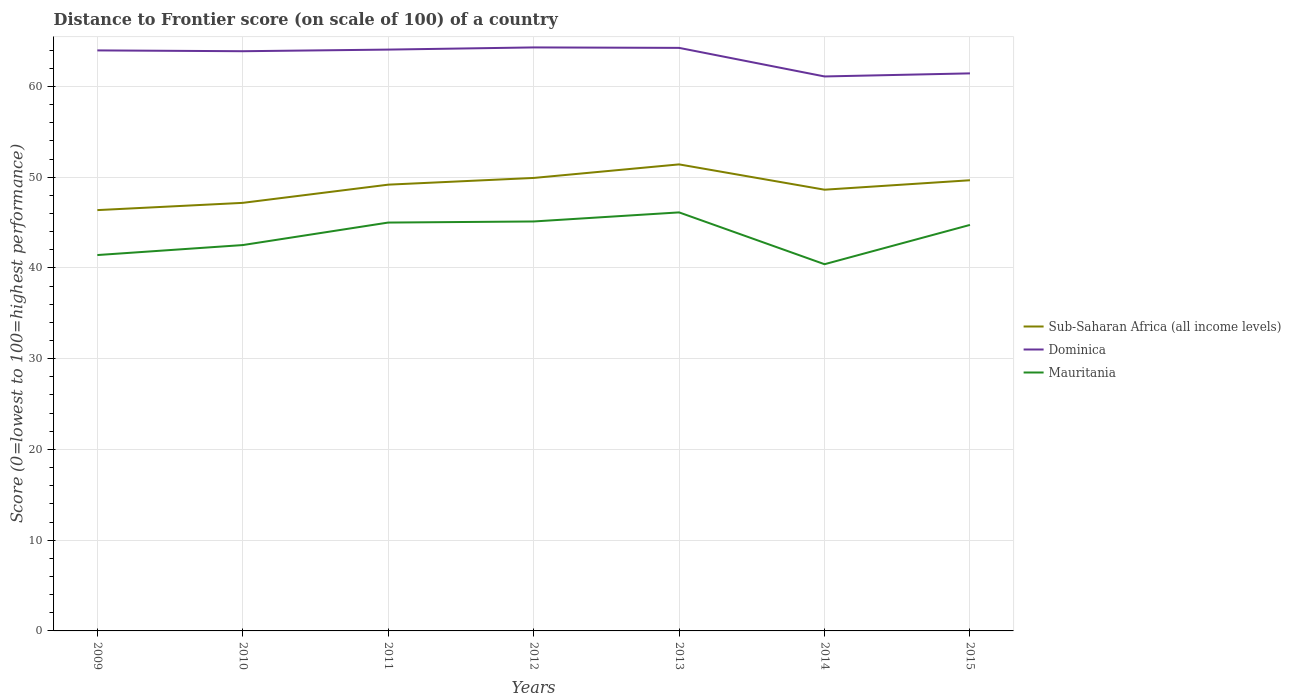How many different coloured lines are there?
Provide a succinct answer. 3. Does the line corresponding to Dominica intersect with the line corresponding to Mauritania?
Your answer should be very brief. No. Across all years, what is the maximum distance to frontier score of in Mauritania?
Give a very brief answer. 40.41. What is the total distance to frontier score of in Dominica in the graph?
Provide a short and direct response. 2.53. What is the difference between the highest and the second highest distance to frontier score of in Sub-Saharan Africa (all income levels)?
Your response must be concise. 5.04. What is the difference between the highest and the lowest distance to frontier score of in Sub-Saharan Africa (all income levels)?
Your answer should be compact. 4. How many years are there in the graph?
Provide a short and direct response. 7. What is the difference between two consecutive major ticks on the Y-axis?
Ensure brevity in your answer.  10. Are the values on the major ticks of Y-axis written in scientific E-notation?
Make the answer very short. No. Does the graph contain any zero values?
Provide a succinct answer. No. Where does the legend appear in the graph?
Keep it short and to the point. Center right. How many legend labels are there?
Your answer should be very brief. 3. What is the title of the graph?
Provide a short and direct response. Distance to Frontier score (on scale of 100) of a country. What is the label or title of the Y-axis?
Give a very brief answer. Score (0=lowest to 100=highest performance). What is the Score (0=lowest to 100=highest performance) of Sub-Saharan Africa (all income levels) in 2009?
Your answer should be very brief. 46.37. What is the Score (0=lowest to 100=highest performance) in Dominica in 2009?
Ensure brevity in your answer.  63.97. What is the Score (0=lowest to 100=highest performance) in Mauritania in 2009?
Provide a short and direct response. 41.42. What is the Score (0=lowest to 100=highest performance) of Sub-Saharan Africa (all income levels) in 2010?
Provide a short and direct response. 47.17. What is the Score (0=lowest to 100=highest performance) of Dominica in 2010?
Keep it short and to the point. 63.88. What is the Score (0=lowest to 100=highest performance) of Mauritania in 2010?
Provide a succinct answer. 42.52. What is the Score (0=lowest to 100=highest performance) of Sub-Saharan Africa (all income levels) in 2011?
Keep it short and to the point. 49.18. What is the Score (0=lowest to 100=highest performance) of Dominica in 2011?
Provide a short and direct response. 64.06. What is the Score (0=lowest to 100=highest performance) of Sub-Saharan Africa (all income levels) in 2012?
Provide a succinct answer. 49.92. What is the Score (0=lowest to 100=highest performance) in Dominica in 2012?
Make the answer very short. 64.3. What is the Score (0=lowest to 100=highest performance) of Mauritania in 2012?
Ensure brevity in your answer.  45.12. What is the Score (0=lowest to 100=highest performance) of Sub-Saharan Africa (all income levels) in 2013?
Ensure brevity in your answer.  51.41. What is the Score (0=lowest to 100=highest performance) in Dominica in 2013?
Ensure brevity in your answer.  64.25. What is the Score (0=lowest to 100=highest performance) of Mauritania in 2013?
Give a very brief answer. 46.12. What is the Score (0=lowest to 100=highest performance) in Sub-Saharan Africa (all income levels) in 2014?
Offer a very short reply. 48.62. What is the Score (0=lowest to 100=highest performance) of Dominica in 2014?
Keep it short and to the point. 61.1. What is the Score (0=lowest to 100=highest performance) in Mauritania in 2014?
Your answer should be very brief. 40.41. What is the Score (0=lowest to 100=highest performance) in Sub-Saharan Africa (all income levels) in 2015?
Make the answer very short. 49.66. What is the Score (0=lowest to 100=highest performance) of Dominica in 2015?
Your answer should be very brief. 61.44. What is the Score (0=lowest to 100=highest performance) in Mauritania in 2015?
Offer a terse response. 44.74. Across all years, what is the maximum Score (0=lowest to 100=highest performance) in Sub-Saharan Africa (all income levels)?
Your answer should be very brief. 51.41. Across all years, what is the maximum Score (0=lowest to 100=highest performance) of Dominica?
Your response must be concise. 64.3. Across all years, what is the maximum Score (0=lowest to 100=highest performance) of Mauritania?
Make the answer very short. 46.12. Across all years, what is the minimum Score (0=lowest to 100=highest performance) of Sub-Saharan Africa (all income levels)?
Make the answer very short. 46.37. Across all years, what is the minimum Score (0=lowest to 100=highest performance) in Dominica?
Offer a terse response. 61.1. Across all years, what is the minimum Score (0=lowest to 100=highest performance) of Mauritania?
Offer a terse response. 40.41. What is the total Score (0=lowest to 100=highest performance) in Sub-Saharan Africa (all income levels) in the graph?
Provide a succinct answer. 342.33. What is the total Score (0=lowest to 100=highest performance) of Dominica in the graph?
Ensure brevity in your answer.  443. What is the total Score (0=lowest to 100=highest performance) in Mauritania in the graph?
Ensure brevity in your answer.  305.33. What is the difference between the Score (0=lowest to 100=highest performance) in Sub-Saharan Africa (all income levels) in 2009 and that in 2010?
Your answer should be compact. -0.8. What is the difference between the Score (0=lowest to 100=highest performance) in Dominica in 2009 and that in 2010?
Your answer should be very brief. 0.09. What is the difference between the Score (0=lowest to 100=highest performance) in Mauritania in 2009 and that in 2010?
Offer a terse response. -1.1. What is the difference between the Score (0=lowest to 100=highest performance) of Sub-Saharan Africa (all income levels) in 2009 and that in 2011?
Your answer should be compact. -2.8. What is the difference between the Score (0=lowest to 100=highest performance) of Dominica in 2009 and that in 2011?
Offer a terse response. -0.09. What is the difference between the Score (0=lowest to 100=highest performance) in Mauritania in 2009 and that in 2011?
Your response must be concise. -3.58. What is the difference between the Score (0=lowest to 100=highest performance) of Sub-Saharan Africa (all income levels) in 2009 and that in 2012?
Give a very brief answer. -3.54. What is the difference between the Score (0=lowest to 100=highest performance) of Dominica in 2009 and that in 2012?
Ensure brevity in your answer.  -0.33. What is the difference between the Score (0=lowest to 100=highest performance) in Sub-Saharan Africa (all income levels) in 2009 and that in 2013?
Give a very brief answer. -5.04. What is the difference between the Score (0=lowest to 100=highest performance) in Dominica in 2009 and that in 2013?
Your response must be concise. -0.28. What is the difference between the Score (0=lowest to 100=highest performance) of Mauritania in 2009 and that in 2013?
Your answer should be very brief. -4.7. What is the difference between the Score (0=lowest to 100=highest performance) in Sub-Saharan Africa (all income levels) in 2009 and that in 2014?
Give a very brief answer. -2.25. What is the difference between the Score (0=lowest to 100=highest performance) in Dominica in 2009 and that in 2014?
Provide a short and direct response. 2.87. What is the difference between the Score (0=lowest to 100=highest performance) of Sub-Saharan Africa (all income levels) in 2009 and that in 2015?
Make the answer very short. -3.29. What is the difference between the Score (0=lowest to 100=highest performance) in Dominica in 2009 and that in 2015?
Provide a short and direct response. 2.53. What is the difference between the Score (0=lowest to 100=highest performance) in Mauritania in 2009 and that in 2015?
Your answer should be compact. -3.32. What is the difference between the Score (0=lowest to 100=highest performance) in Sub-Saharan Africa (all income levels) in 2010 and that in 2011?
Make the answer very short. -2.01. What is the difference between the Score (0=lowest to 100=highest performance) in Dominica in 2010 and that in 2011?
Provide a short and direct response. -0.18. What is the difference between the Score (0=lowest to 100=highest performance) of Mauritania in 2010 and that in 2011?
Your response must be concise. -2.48. What is the difference between the Score (0=lowest to 100=highest performance) in Sub-Saharan Africa (all income levels) in 2010 and that in 2012?
Ensure brevity in your answer.  -2.75. What is the difference between the Score (0=lowest to 100=highest performance) of Dominica in 2010 and that in 2012?
Provide a succinct answer. -0.42. What is the difference between the Score (0=lowest to 100=highest performance) of Sub-Saharan Africa (all income levels) in 2010 and that in 2013?
Your response must be concise. -4.24. What is the difference between the Score (0=lowest to 100=highest performance) of Dominica in 2010 and that in 2013?
Offer a very short reply. -0.37. What is the difference between the Score (0=lowest to 100=highest performance) of Sub-Saharan Africa (all income levels) in 2010 and that in 2014?
Your response must be concise. -1.45. What is the difference between the Score (0=lowest to 100=highest performance) in Dominica in 2010 and that in 2014?
Make the answer very short. 2.78. What is the difference between the Score (0=lowest to 100=highest performance) in Mauritania in 2010 and that in 2014?
Give a very brief answer. 2.11. What is the difference between the Score (0=lowest to 100=highest performance) of Sub-Saharan Africa (all income levels) in 2010 and that in 2015?
Offer a very short reply. -2.49. What is the difference between the Score (0=lowest to 100=highest performance) of Dominica in 2010 and that in 2015?
Give a very brief answer. 2.44. What is the difference between the Score (0=lowest to 100=highest performance) in Mauritania in 2010 and that in 2015?
Provide a succinct answer. -2.22. What is the difference between the Score (0=lowest to 100=highest performance) in Sub-Saharan Africa (all income levels) in 2011 and that in 2012?
Your response must be concise. -0.74. What is the difference between the Score (0=lowest to 100=highest performance) in Dominica in 2011 and that in 2012?
Make the answer very short. -0.24. What is the difference between the Score (0=lowest to 100=highest performance) of Mauritania in 2011 and that in 2012?
Keep it short and to the point. -0.12. What is the difference between the Score (0=lowest to 100=highest performance) of Sub-Saharan Africa (all income levels) in 2011 and that in 2013?
Your response must be concise. -2.23. What is the difference between the Score (0=lowest to 100=highest performance) in Dominica in 2011 and that in 2013?
Your response must be concise. -0.19. What is the difference between the Score (0=lowest to 100=highest performance) in Mauritania in 2011 and that in 2013?
Provide a succinct answer. -1.12. What is the difference between the Score (0=lowest to 100=highest performance) in Sub-Saharan Africa (all income levels) in 2011 and that in 2014?
Your answer should be very brief. 0.56. What is the difference between the Score (0=lowest to 100=highest performance) of Dominica in 2011 and that in 2014?
Ensure brevity in your answer.  2.96. What is the difference between the Score (0=lowest to 100=highest performance) in Mauritania in 2011 and that in 2014?
Give a very brief answer. 4.59. What is the difference between the Score (0=lowest to 100=highest performance) in Sub-Saharan Africa (all income levels) in 2011 and that in 2015?
Give a very brief answer. -0.49. What is the difference between the Score (0=lowest to 100=highest performance) of Dominica in 2011 and that in 2015?
Provide a succinct answer. 2.62. What is the difference between the Score (0=lowest to 100=highest performance) of Mauritania in 2011 and that in 2015?
Provide a succinct answer. 0.26. What is the difference between the Score (0=lowest to 100=highest performance) in Sub-Saharan Africa (all income levels) in 2012 and that in 2013?
Your answer should be compact. -1.49. What is the difference between the Score (0=lowest to 100=highest performance) in Sub-Saharan Africa (all income levels) in 2012 and that in 2014?
Your answer should be very brief. 1.3. What is the difference between the Score (0=lowest to 100=highest performance) in Mauritania in 2012 and that in 2014?
Give a very brief answer. 4.71. What is the difference between the Score (0=lowest to 100=highest performance) of Sub-Saharan Africa (all income levels) in 2012 and that in 2015?
Keep it short and to the point. 0.25. What is the difference between the Score (0=lowest to 100=highest performance) of Dominica in 2012 and that in 2015?
Give a very brief answer. 2.86. What is the difference between the Score (0=lowest to 100=highest performance) of Mauritania in 2012 and that in 2015?
Provide a succinct answer. 0.38. What is the difference between the Score (0=lowest to 100=highest performance) of Sub-Saharan Africa (all income levels) in 2013 and that in 2014?
Give a very brief answer. 2.79. What is the difference between the Score (0=lowest to 100=highest performance) in Dominica in 2013 and that in 2014?
Offer a terse response. 3.15. What is the difference between the Score (0=lowest to 100=highest performance) of Mauritania in 2013 and that in 2014?
Ensure brevity in your answer.  5.71. What is the difference between the Score (0=lowest to 100=highest performance) of Sub-Saharan Africa (all income levels) in 2013 and that in 2015?
Offer a very short reply. 1.75. What is the difference between the Score (0=lowest to 100=highest performance) in Dominica in 2013 and that in 2015?
Your answer should be compact. 2.81. What is the difference between the Score (0=lowest to 100=highest performance) of Mauritania in 2013 and that in 2015?
Provide a short and direct response. 1.38. What is the difference between the Score (0=lowest to 100=highest performance) of Sub-Saharan Africa (all income levels) in 2014 and that in 2015?
Give a very brief answer. -1.04. What is the difference between the Score (0=lowest to 100=highest performance) of Dominica in 2014 and that in 2015?
Provide a short and direct response. -0.34. What is the difference between the Score (0=lowest to 100=highest performance) in Mauritania in 2014 and that in 2015?
Make the answer very short. -4.33. What is the difference between the Score (0=lowest to 100=highest performance) of Sub-Saharan Africa (all income levels) in 2009 and the Score (0=lowest to 100=highest performance) of Dominica in 2010?
Your answer should be very brief. -17.51. What is the difference between the Score (0=lowest to 100=highest performance) of Sub-Saharan Africa (all income levels) in 2009 and the Score (0=lowest to 100=highest performance) of Mauritania in 2010?
Provide a succinct answer. 3.85. What is the difference between the Score (0=lowest to 100=highest performance) in Dominica in 2009 and the Score (0=lowest to 100=highest performance) in Mauritania in 2010?
Ensure brevity in your answer.  21.45. What is the difference between the Score (0=lowest to 100=highest performance) in Sub-Saharan Africa (all income levels) in 2009 and the Score (0=lowest to 100=highest performance) in Dominica in 2011?
Give a very brief answer. -17.69. What is the difference between the Score (0=lowest to 100=highest performance) in Sub-Saharan Africa (all income levels) in 2009 and the Score (0=lowest to 100=highest performance) in Mauritania in 2011?
Offer a terse response. 1.37. What is the difference between the Score (0=lowest to 100=highest performance) in Dominica in 2009 and the Score (0=lowest to 100=highest performance) in Mauritania in 2011?
Offer a terse response. 18.97. What is the difference between the Score (0=lowest to 100=highest performance) of Sub-Saharan Africa (all income levels) in 2009 and the Score (0=lowest to 100=highest performance) of Dominica in 2012?
Your answer should be very brief. -17.93. What is the difference between the Score (0=lowest to 100=highest performance) of Sub-Saharan Africa (all income levels) in 2009 and the Score (0=lowest to 100=highest performance) of Mauritania in 2012?
Your answer should be very brief. 1.25. What is the difference between the Score (0=lowest to 100=highest performance) in Dominica in 2009 and the Score (0=lowest to 100=highest performance) in Mauritania in 2012?
Offer a very short reply. 18.85. What is the difference between the Score (0=lowest to 100=highest performance) of Sub-Saharan Africa (all income levels) in 2009 and the Score (0=lowest to 100=highest performance) of Dominica in 2013?
Your answer should be compact. -17.88. What is the difference between the Score (0=lowest to 100=highest performance) in Sub-Saharan Africa (all income levels) in 2009 and the Score (0=lowest to 100=highest performance) in Mauritania in 2013?
Your response must be concise. 0.25. What is the difference between the Score (0=lowest to 100=highest performance) in Dominica in 2009 and the Score (0=lowest to 100=highest performance) in Mauritania in 2013?
Ensure brevity in your answer.  17.85. What is the difference between the Score (0=lowest to 100=highest performance) in Sub-Saharan Africa (all income levels) in 2009 and the Score (0=lowest to 100=highest performance) in Dominica in 2014?
Give a very brief answer. -14.73. What is the difference between the Score (0=lowest to 100=highest performance) of Sub-Saharan Africa (all income levels) in 2009 and the Score (0=lowest to 100=highest performance) of Mauritania in 2014?
Offer a very short reply. 5.96. What is the difference between the Score (0=lowest to 100=highest performance) of Dominica in 2009 and the Score (0=lowest to 100=highest performance) of Mauritania in 2014?
Provide a succinct answer. 23.56. What is the difference between the Score (0=lowest to 100=highest performance) in Sub-Saharan Africa (all income levels) in 2009 and the Score (0=lowest to 100=highest performance) in Dominica in 2015?
Give a very brief answer. -15.07. What is the difference between the Score (0=lowest to 100=highest performance) in Sub-Saharan Africa (all income levels) in 2009 and the Score (0=lowest to 100=highest performance) in Mauritania in 2015?
Your answer should be compact. 1.63. What is the difference between the Score (0=lowest to 100=highest performance) in Dominica in 2009 and the Score (0=lowest to 100=highest performance) in Mauritania in 2015?
Ensure brevity in your answer.  19.23. What is the difference between the Score (0=lowest to 100=highest performance) of Sub-Saharan Africa (all income levels) in 2010 and the Score (0=lowest to 100=highest performance) of Dominica in 2011?
Your response must be concise. -16.89. What is the difference between the Score (0=lowest to 100=highest performance) of Sub-Saharan Africa (all income levels) in 2010 and the Score (0=lowest to 100=highest performance) of Mauritania in 2011?
Keep it short and to the point. 2.17. What is the difference between the Score (0=lowest to 100=highest performance) in Dominica in 2010 and the Score (0=lowest to 100=highest performance) in Mauritania in 2011?
Make the answer very short. 18.88. What is the difference between the Score (0=lowest to 100=highest performance) in Sub-Saharan Africa (all income levels) in 2010 and the Score (0=lowest to 100=highest performance) in Dominica in 2012?
Offer a very short reply. -17.13. What is the difference between the Score (0=lowest to 100=highest performance) in Sub-Saharan Africa (all income levels) in 2010 and the Score (0=lowest to 100=highest performance) in Mauritania in 2012?
Your answer should be compact. 2.05. What is the difference between the Score (0=lowest to 100=highest performance) of Dominica in 2010 and the Score (0=lowest to 100=highest performance) of Mauritania in 2012?
Your response must be concise. 18.76. What is the difference between the Score (0=lowest to 100=highest performance) of Sub-Saharan Africa (all income levels) in 2010 and the Score (0=lowest to 100=highest performance) of Dominica in 2013?
Offer a very short reply. -17.08. What is the difference between the Score (0=lowest to 100=highest performance) in Sub-Saharan Africa (all income levels) in 2010 and the Score (0=lowest to 100=highest performance) in Mauritania in 2013?
Make the answer very short. 1.05. What is the difference between the Score (0=lowest to 100=highest performance) of Dominica in 2010 and the Score (0=lowest to 100=highest performance) of Mauritania in 2013?
Your response must be concise. 17.76. What is the difference between the Score (0=lowest to 100=highest performance) in Sub-Saharan Africa (all income levels) in 2010 and the Score (0=lowest to 100=highest performance) in Dominica in 2014?
Provide a short and direct response. -13.93. What is the difference between the Score (0=lowest to 100=highest performance) in Sub-Saharan Africa (all income levels) in 2010 and the Score (0=lowest to 100=highest performance) in Mauritania in 2014?
Your response must be concise. 6.76. What is the difference between the Score (0=lowest to 100=highest performance) of Dominica in 2010 and the Score (0=lowest to 100=highest performance) of Mauritania in 2014?
Provide a succinct answer. 23.47. What is the difference between the Score (0=lowest to 100=highest performance) in Sub-Saharan Africa (all income levels) in 2010 and the Score (0=lowest to 100=highest performance) in Dominica in 2015?
Your answer should be very brief. -14.27. What is the difference between the Score (0=lowest to 100=highest performance) in Sub-Saharan Africa (all income levels) in 2010 and the Score (0=lowest to 100=highest performance) in Mauritania in 2015?
Your answer should be compact. 2.43. What is the difference between the Score (0=lowest to 100=highest performance) in Dominica in 2010 and the Score (0=lowest to 100=highest performance) in Mauritania in 2015?
Provide a short and direct response. 19.14. What is the difference between the Score (0=lowest to 100=highest performance) of Sub-Saharan Africa (all income levels) in 2011 and the Score (0=lowest to 100=highest performance) of Dominica in 2012?
Offer a very short reply. -15.12. What is the difference between the Score (0=lowest to 100=highest performance) of Sub-Saharan Africa (all income levels) in 2011 and the Score (0=lowest to 100=highest performance) of Mauritania in 2012?
Your answer should be compact. 4.06. What is the difference between the Score (0=lowest to 100=highest performance) of Dominica in 2011 and the Score (0=lowest to 100=highest performance) of Mauritania in 2012?
Provide a short and direct response. 18.94. What is the difference between the Score (0=lowest to 100=highest performance) of Sub-Saharan Africa (all income levels) in 2011 and the Score (0=lowest to 100=highest performance) of Dominica in 2013?
Your response must be concise. -15.07. What is the difference between the Score (0=lowest to 100=highest performance) of Sub-Saharan Africa (all income levels) in 2011 and the Score (0=lowest to 100=highest performance) of Mauritania in 2013?
Your answer should be compact. 3.06. What is the difference between the Score (0=lowest to 100=highest performance) in Dominica in 2011 and the Score (0=lowest to 100=highest performance) in Mauritania in 2013?
Your response must be concise. 17.94. What is the difference between the Score (0=lowest to 100=highest performance) of Sub-Saharan Africa (all income levels) in 2011 and the Score (0=lowest to 100=highest performance) of Dominica in 2014?
Keep it short and to the point. -11.92. What is the difference between the Score (0=lowest to 100=highest performance) in Sub-Saharan Africa (all income levels) in 2011 and the Score (0=lowest to 100=highest performance) in Mauritania in 2014?
Your response must be concise. 8.77. What is the difference between the Score (0=lowest to 100=highest performance) of Dominica in 2011 and the Score (0=lowest to 100=highest performance) of Mauritania in 2014?
Provide a short and direct response. 23.65. What is the difference between the Score (0=lowest to 100=highest performance) in Sub-Saharan Africa (all income levels) in 2011 and the Score (0=lowest to 100=highest performance) in Dominica in 2015?
Ensure brevity in your answer.  -12.26. What is the difference between the Score (0=lowest to 100=highest performance) in Sub-Saharan Africa (all income levels) in 2011 and the Score (0=lowest to 100=highest performance) in Mauritania in 2015?
Make the answer very short. 4.44. What is the difference between the Score (0=lowest to 100=highest performance) of Dominica in 2011 and the Score (0=lowest to 100=highest performance) of Mauritania in 2015?
Offer a terse response. 19.32. What is the difference between the Score (0=lowest to 100=highest performance) of Sub-Saharan Africa (all income levels) in 2012 and the Score (0=lowest to 100=highest performance) of Dominica in 2013?
Make the answer very short. -14.33. What is the difference between the Score (0=lowest to 100=highest performance) of Sub-Saharan Africa (all income levels) in 2012 and the Score (0=lowest to 100=highest performance) of Mauritania in 2013?
Your response must be concise. 3.8. What is the difference between the Score (0=lowest to 100=highest performance) of Dominica in 2012 and the Score (0=lowest to 100=highest performance) of Mauritania in 2013?
Your response must be concise. 18.18. What is the difference between the Score (0=lowest to 100=highest performance) of Sub-Saharan Africa (all income levels) in 2012 and the Score (0=lowest to 100=highest performance) of Dominica in 2014?
Provide a succinct answer. -11.18. What is the difference between the Score (0=lowest to 100=highest performance) in Sub-Saharan Africa (all income levels) in 2012 and the Score (0=lowest to 100=highest performance) in Mauritania in 2014?
Ensure brevity in your answer.  9.51. What is the difference between the Score (0=lowest to 100=highest performance) in Dominica in 2012 and the Score (0=lowest to 100=highest performance) in Mauritania in 2014?
Make the answer very short. 23.89. What is the difference between the Score (0=lowest to 100=highest performance) of Sub-Saharan Africa (all income levels) in 2012 and the Score (0=lowest to 100=highest performance) of Dominica in 2015?
Your answer should be compact. -11.52. What is the difference between the Score (0=lowest to 100=highest performance) of Sub-Saharan Africa (all income levels) in 2012 and the Score (0=lowest to 100=highest performance) of Mauritania in 2015?
Keep it short and to the point. 5.18. What is the difference between the Score (0=lowest to 100=highest performance) in Dominica in 2012 and the Score (0=lowest to 100=highest performance) in Mauritania in 2015?
Make the answer very short. 19.56. What is the difference between the Score (0=lowest to 100=highest performance) of Sub-Saharan Africa (all income levels) in 2013 and the Score (0=lowest to 100=highest performance) of Dominica in 2014?
Ensure brevity in your answer.  -9.69. What is the difference between the Score (0=lowest to 100=highest performance) in Sub-Saharan Africa (all income levels) in 2013 and the Score (0=lowest to 100=highest performance) in Mauritania in 2014?
Make the answer very short. 11. What is the difference between the Score (0=lowest to 100=highest performance) of Dominica in 2013 and the Score (0=lowest to 100=highest performance) of Mauritania in 2014?
Provide a short and direct response. 23.84. What is the difference between the Score (0=lowest to 100=highest performance) of Sub-Saharan Africa (all income levels) in 2013 and the Score (0=lowest to 100=highest performance) of Dominica in 2015?
Offer a terse response. -10.03. What is the difference between the Score (0=lowest to 100=highest performance) of Sub-Saharan Africa (all income levels) in 2013 and the Score (0=lowest to 100=highest performance) of Mauritania in 2015?
Give a very brief answer. 6.67. What is the difference between the Score (0=lowest to 100=highest performance) of Dominica in 2013 and the Score (0=lowest to 100=highest performance) of Mauritania in 2015?
Offer a terse response. 19.51. What is the difference between the Score (0=lowest to 100=highest performance) of Sub-Saharan Africa (all income levels) in 2014 and the Score (0=lowest to 100=highest performance) of Dominica in 2015?
Keep it short and to the point. -12.82. What is the difference between the Score (0=lowest to 100=highest performance) of Sub-Saharan Africa (all income levels) in 2014 and the Score (0=lowest to 100=highest performance) of Mauritania in 2015?
Provide a succinct answer. 3.88. What is the difference between the Score (0=lowest to 100=highest performance) in Dominica in 2014 and the Score (0=lowest to 100=highest performance) in Mauritania in 2015?
Make the answer very short. 16.36. What is the average Score (0=lowest to 100=highest performance) in Sub-Saharan Africa (all income levels) per year?
Give a very brief answer. 48.9. What is the average Score (0=lowest to 100=highest performance) of Dominica per year?
Keep it short and to the point. 63.29. What is the average Score (0=lowest to 100=highest performance) of Mauritania per year?
Your answer should be very brief. 43.62. In the year 2009, what is the difference between the Score (0=lowest to 100=highest performance) in Sub-Saharan Africa (all income levels) and Score (0=lowest to 100=highest performance) in Dominica?
Provide a succinct answer. -17.6. In the year 2009, what is the difference between the Score (0=lowest to 100=highest performance) in Sub-Saharan Africa (all income levels) and Score (0=lowest to 100=highest performance) in Mauritania?
Provide a succinct answer. 4.95. In the year 2009, what is the difference between the Score (0=lowest to 100=highest performance) of Dominica and Score (0=lowest to 100=highest performance) of Mauritania?
Offer a very short reply. 22.55. In the year 2010, what is the difference between the Score (0=lowest to 100=highest performance) in Sub-Saharan Africa (all income levels) and Score (0=lowest to 100=highest performance) in Dominica?
Your answer should be compact. -16.71. In the year 2010, what is the difference between the Score (0=lowest to 100=highest performance) in Sub-Saharan Africa (all income levels) and Score (0=lowest to 100=highest performance) in Mauritania?
Your answer should be very brief. 4.65. In the year 2010, what is the difference between the Score (0=lowest to 100=highest performance) in Dominica and Score (0=lowest to 100=highest performance) in Mauritania?
Your answer should be very brief. 21.36. In the year 2011, what is the difference between the Score (0=lowest to 100=highest performance) in Sub-Saharan Africa (all income levels) and Score (0=lowest to 100=highest performance) in Dominica?
Offer a very short reply. -14.88. In the year 2011, what is the difference between the Score (0=lowest to 100=highest performance) of Sub-Saharan Africa (all income levels) and Score (0=lowest to 100=highest performance) of Mauritania?
Give a very brief answer. 4.18. In the year 2011, what is the difference between the Score (0=lowest to 100=highest performance) in Dominica and Score (0=lowest to 100=highest performance) in Mauritania?
Provide a succinct answer. 19.06. In the year 2012, what is the difference between the Score (0=lowest to 100=highest performance) of Sub-Saharan Africa (all income levels) and Score (0=lowest to 100=highest performance) of Dominica?
Your answer should be very brief. -14.38. In the year 2012, what is the difference between the Score (0=lowest to 100=highest performance) in Sub-Saharan Africa (all income levels) and Score (0=lowest to 100=highest performance) in Mauritania?
Offer a very short reply. 4.8. In the year 2012, what is the difference between the Score (0=lowest to 100=highest performance) of Dominica and Score (0=lowest to 100=highest performance) of Mauritania?
Your answer should be very brief. 19.18. In the year 2013, what is the difference between the Score (0=lowest to 100=highest performance) of Sub-Saharan Africa (all income levels) and Score (0=lowest to 100=highest performance) of Dominica?
Offer a terse response. -12.84. In the year 2013, what is the difference between the Score (0=lowest to 100=highest performance) of Sub-Saharan Africa (all income levels) and Score (0=lowest to 100=highest performance) of Mauritania?
Keep it short and to the point. 5.29. In the year 2013, what is the difference between the Score (0=lowest to 100=highest performance) in Dominica and Score (0=lowest to 100=highest performance) in Mauritania?
Offer a terse response. 18.13. In the year 2014, what is the difference between the Score (0=lowest to 100=highest performance) of Sub-Saharan Africa (all income levels) and Score (0=lowest to 100=highest performance) of Dominica?
Provide a short and direct response. -12.48. In the year 2014, what is the difference between the Score (0=lowest to 100=highest performance) of Sub-Saharan Africa (all income levels) and Score (0=lowest to 100=highest performance) of Mauritania?
Keep it short and to the point. 8.21. In the year 2014, what is the difference between the Score (0=lowest to 100=highest performance) of Dominica and Score (0=lowest to 100=highest performance) of Mauritania?
Offer a very short reply. 20.69. In the year 2015, what is the difference between the Score (0=lowest to 100=highest performance) in Sub-Saharan Africa (all income levels) and Score (0=lowest to 100=highest performance) in Dominica?
Give a very brief answer. -11.78. In the year 2015, what is the difference between the Score (0=lowest to 100=highest performance) in Sub-Saharan Africa (all income levels) and Score (0=lowest to 100=highest performance) in Mauritania?
Your answer should be very brief. 4.92. What is the ratio of the Score (0=lowest to 100=highest performance) of Sub-Saharan Africa (all income levels) in 2009 to that in 2010?
Provide a short and direct response. 0.98. What is the ratio of the Score (0=lowest to 100=highest performance) of Mauritania in 2009 to that in 2010?
Make the answer very short. 0.97. What is the ratio of the Score (0=lowest to 100=highest performance) of Sub-Saharan Africa (all income levels) in 2009 to that in 2011?
Provide a succinct answer. 0.94. What is the ratio of the Score (0=lowest to 100=highest performance) in Dominica in 2009 to that in 2011?
Provide a succinct answer. 1. What is the ratio of the Score (0=lowest to 100=highest performance) of Mauritania in 2009 to that in 2011?
Ensure brevity in your answer.  0.92. What is the ratio of the Score (0=lowest to 100=highest performance) of Sub-Saharan Africa (all income levels) in 2009 to that in 2012?
Your answer should be compact. 0.93. What is the ratio of the Score (0=lowest to 100=highest performance) of Mauritania in 2009 to that in 2012?
Your response must be concise. 0.92. What is the ratio of the Score (0=lowest to 100=highest performance) of Sub-Saharan Africa (all income levels) in 2009 to that in 2013?
Offer a very short reply. 0.9. What is the ratio of the Score (0=lowest to 100=highest performance) in Mauritania in 2009 to that in 2013?
Provide a short and direct response. 0.9. What is the ratio of the Score (0=lowest to 100=highest performance) in Sub-Saharan Africa (all income levels) in 2009 to that in 2014?
Your response must be concise. 0.95. What is the ratio of the Score (0=lowest to 100=highest performance) in Dominica in 2009 to that in 2014?
Keep it short and to the point. 1.05. What is the ratio of the Score (0=lowest to 100=highest performance) in Mauritania in 2009 to that in 2014?
Keep it short and to the point. 1.02. What is the ratio of the Score (0=lowest to 100=highest performance) in Sub-Saharan Africa (all income levels) in 2009 to that in 2015?
Keep it short and to the point. 0.93. What is the ratio of the Score (0=lowest to 100=highest performance) of Dominica in 2009 to that in 2015?
Provide a succinct answer. 1.04. What is the ratio of the Score (0=lowest to 100=highest performance) of Mauritania in 2009 to that in 2015?
Offer a very short reply. 0.93. What is the ratio of the Score (0=lowest to 100=highest performance) of Sub-Saharan Africa (all income levels) in 2010 to that in 2011?
Ensure brevity in your answer.  0.96. What is the ratio of the Score (0=lowest to 100=highest performance) in Mauritania in 2010 to that in 2011?
Offer a very short reply. 0.94. What is the ratio of the Score (0=lowest to 100=highest performance) of Sub-Saharan Africa (all income levels) in 2010 to that in 2012?
Give a very brief answer. 0.94. What is the ratio of the Score (0=lowest to 100=highest performance) in Dominica in 2010 to that in 2012?
Your response must be concise. 0.99. What is the ratio of the Score (0=lowest to 100=highest performance) of Mauritania in 2010 to that in 2012?
Your answer should be compact. 0.94. What is the ratio of the Score (0=lowest to 100=highest performance) in Sub-Saharan Africa (all income levels) in 2010 to that in 2013?
Your response must be concise. 0.92. What is the ratio of the Score (0=lowest to 100=highest performance) of Dominica in 2010 to that in 2013?
Keep it short and to the point. 0.99. What is the ratio of the Score (0=lowest to 100=highest performance) of Mauritania in 2010 to that in 2013?
Your answer should be very brief. 0.92. What is the ratio of the Score (0=lowest to 100=highest performance) in Sub-Saharan Africa (all income levels) in 2010 to that in 2014?
Your answer should be compact. 0.97. What is the ratio of the Score (0=lowest to 100=highest performance) of Dominica in 2010 to that in 2014?
Keep it short and to the point. 1.05. What is the ratio of the Score (0=lowest to 100=highest performance) of Mauritania in 2010 to that in 2014?
Offer a terse response. 1.05. What is the ratio of the Score (0=lowest to 100=highest performance) in Sub-Saharan Africa (all income levels) in 2010 to that in 2015?
Offer a terse response. 0.95. What is the ratio of the Score (0=lowest to 100=highest performance) of Dominica in 2010 to that in 2015?
Make the answer very short. 1.04. What is the ratio of the Score (0=lowest to 100=highest performance) in Mauritania in 2010 to that in 2015?
Provide a succinct answer. 0.95. What is the ratio of the Score (0=lowest to 100=highest performance) in Sub-Saharan Africa (all income levels) in 2011 to that in 2012?
Offer a very short reply. 0.99. What is the ratio of the Score (0=lowest to 100=highest performance) in Dominica in 2011 to that in 2012?
Offer a very short reply. 1. What is the ratio of the Score (0=lowest to 100=highest performance) in Mauritania in 2011 to that in 2012?
Make the answer very short. 1. What is the ratio of the Score (0=lowest to 100=highest performance) of Sub-Saharan Africa (all income levels) in 2011 to that in 2013?
Provide a succinct answer. 0.96. What is the ratio of the Score (0=lowest to 100=highest performance) in Mauritania in 2011 to that in 2013?
Your answer should be compact. 0.98. What is the ratio of the Score (0=lowest to 100=highest performance) of Sub-Saharan Africa (all income levels) in 2011 to that in 2014?
Give a very brief answer. 1.01. What is the ratio of the Score (0=lowest to 100=highest performance) of Dominica in 2011 to that in 2014?
Offer a very short reply. 1.05. What is the ratio of the Score (0=lowest to 100=highest performance) of Mauritania in 2011 to that in 2014?
Keep it short and to the point. 1.11. What is the ratio of the Score (0=lowest to 100=highest performance) of Sub-Saharan Africa (all income levels) in 2011 to that in 2015?
Keep it short and to the point. 0.99. What is the ratio of the Score (0=lowest to 100=highest performance) of Dominica in 2011 to that in 2015?
Keep it short and to the point. 1.04. What is the ratio of the Score (0=lowest to 100=highest performance) of Mauritania in 2011 to that in 2015?
Give a very brief answer. 1.01. What is the ratio of the Score (0=lowest to 100=highest performance) in Sub-Saharan Africa (all income levels) in 2012 to that in 2013?
Your answer should be very brief. 0.97. What is the ratio of the Score (0=lowest to 100=highest performance) in Dominica in 2012 to that in 2013?
Give a very brief answer. 1. What is the ratio of the Score (0=lowest to 100=highest performance) of Mauritania in 2012 to that in 2013?
Your answer should be very brief. 0.98. What is the ratio of the Score (0=lowest to 100=highest performance) of Sub-Saharan Africa (all income levels) in 2012 to that in 2014?
Your answer should be compact. 1.03. What is the ratio of the Score (0=lowest to 100=highest performance) in Dominica in 2012 to that in 2014?
Offer a terse response. 1.05. What is the ratio of the Score (0=lowest to 100=highest performance) in Mauritania in 2012 to that in 2014?
Ensure brevity in your answer.  1.12. What is the ratio of the Score (0=lowest to 100=highest performance) of Dominica in 2012 to that in 2015?
Provide a succinct answer. 1.05. What is the ratio of the Score (0=lowest to 100=highest performance) of Mauritania in 2012 to that in 2015?
Make the answer very short. 1.01. What is the ratio of the Score (0=lowest to 100=highest performance) of Sub-Saharan Africa (all income levels) in 2013 to that in 2014?
Provide a succinct answer. 1.06. What is the ratio of the Score (0=lowest to 100=highest performance) of Dominica in 2013 to that in 2014?
Provide a short and direct response. 1.05. What is the ratio of the Score (0=lowest to 100=highest performance) in Mauritania in 2013 to that in 2014?
Provide a short and direct response. 1.14. What is the ratio of the Score (0=lowest to 100=highest performance) in Sub-Saharan Africa (all income levels) in 2013 to that in 2015?
Provide a short and direct response. 1.04. What is the ratio of the Score (0=lowest to 100=highest performance) in Dominica in 2013 to that in 2015?
Your answer should be compact. 1.05. What is the ratio of the Score (0=lowest to 100=highest performance) of Mauritania in 2013 to that in 2015?
Your answer should be compact. 1.03. What is the ratio of the Score (0=lowest to 100=highest performance) of Sub-Saharan Africa (all income levels) in 2014 to that in 2015?
Offer a terse response. 0.98. What is the ratio of the Score (0=lowest to 100=highest performance) in Mauritania in 2014 to that in 2015?
Make the answer very short. 0.9. What is the difference between the highest and the second highest Score (0=lowest to 100=highest performance) of Sub-Saharan Africa (all income levels)?
Give a very brief answer. 1.49. What is the difference between the highest and the second highest Score (0=lowest to 100=highest performance) of Dominica?
Provide a succinct answer. 0.05. What is the difference between the highest and the second highest Score (0=lowest to 100=highest performance) of Mauritania?
Keep it short and to the point. 1. What is the difference between the highest and the lowest Score (0=lowest to 100=highest performance) of Sub-Saharan Africa (all income levels)?
Provide a succinct answer. 5.04. What is the difference between the highest and the lowest Score (0=lowest to 100=highest performance) in Mauritania?
Make the answer very short. 5.71. 